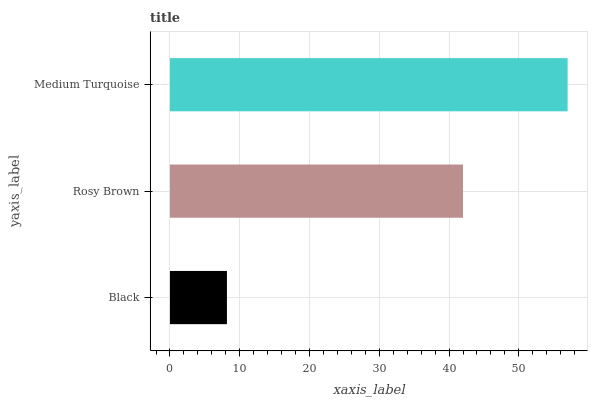Is Black the minimum?
Answer yes or no. Yes. Is Medium Turquoise the maximum?
Answer yes or no. Yes. Is Rosy Brown the minimum?
Answer yes or no. No. Is Rosy Brown the maximum?
Answer yes or no. No. Is Rosy Brown greater than Black?
Answer yes or no. Yes. Is Black less than Rosy Brown?
Answer yes or no. Yes. Is Black greater than Rosy Brown?
Answer yes or no. No. Is Rosy Brown less than Black?
Answer yes or no. No. Is Rosy Brown the high median?
Answer yes or no. Yes. Is Rosy Brown the low median?
Answer yes or no. Yes. Is Black the high median?
Answer yes or no. No. Is Medium Turquoise the low median?
Answer yes or no. No. 